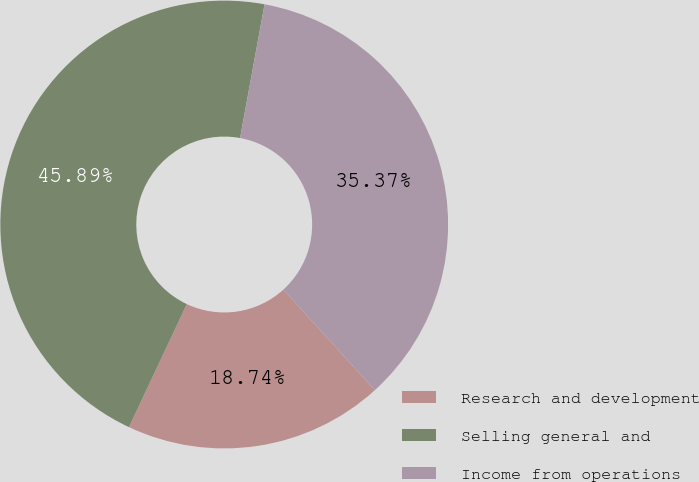Convert chart to OTSL. <chart><loc_0><loc_0><loc_500><loc_500><pie_chart><fcel>Research and development<fcel>Selling general and<fcel>Income from operations<nl><fcel>18.74%<fcel>45.89%<fcel>35.37%<nl></chart> 